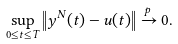<formula> <loc_0><loc_0><loc_500><loc_500>& \sup _ { 0 \leq t \leq T } \left \| y ^ { N } ( t ) - u ( t ) \right \| \xrightarrow { p } 0 .</formula> 